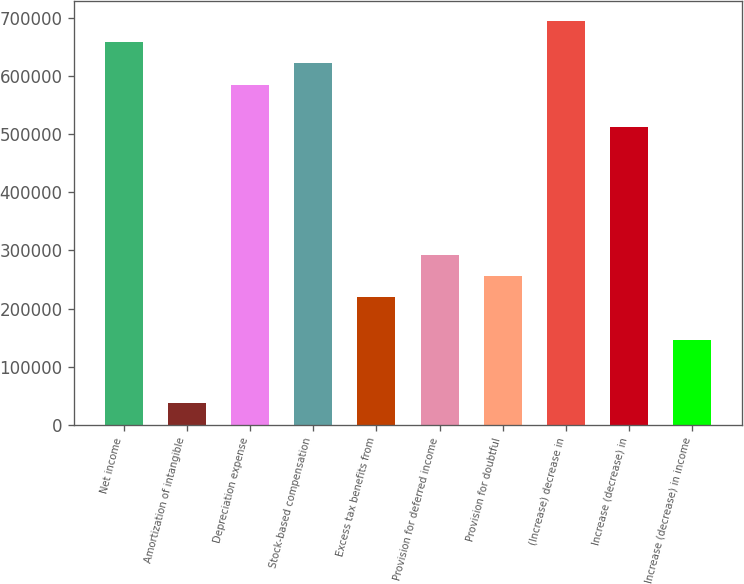<chart> <loc_0><loc_0><loc_500><loc_500><bar_chart><fcel>Net income<fcel>Amortization of intangible<fcel>Depreciation expense<fcel>Stock-based compensation<fcel>Excess tax benefits from<fcel>Provision for deferred income<fcel>Provision for doubtful<fcel>(Increase) decrease in<fcel>Increase (decrease) in<fcel>Increase (decrease) in income<nl><fcel>658339<fcel>36681.1<fcel>585203<fcel>621771<fcel>219522<fcel>292658<fcel>256090<fcel>694907<fcel>512066<fcel>146385<nl></chart> 